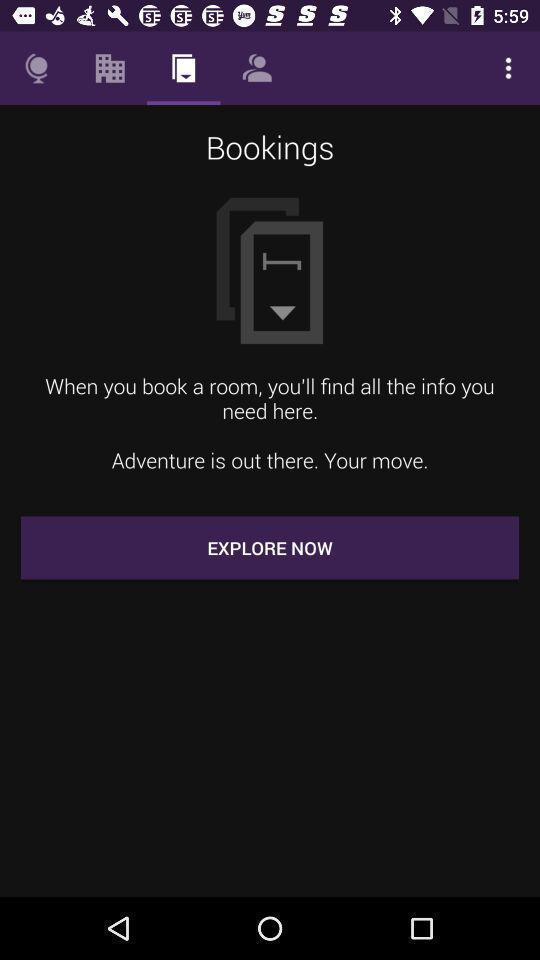Describe the key features of this screenshot. Screen displaying booking page. 